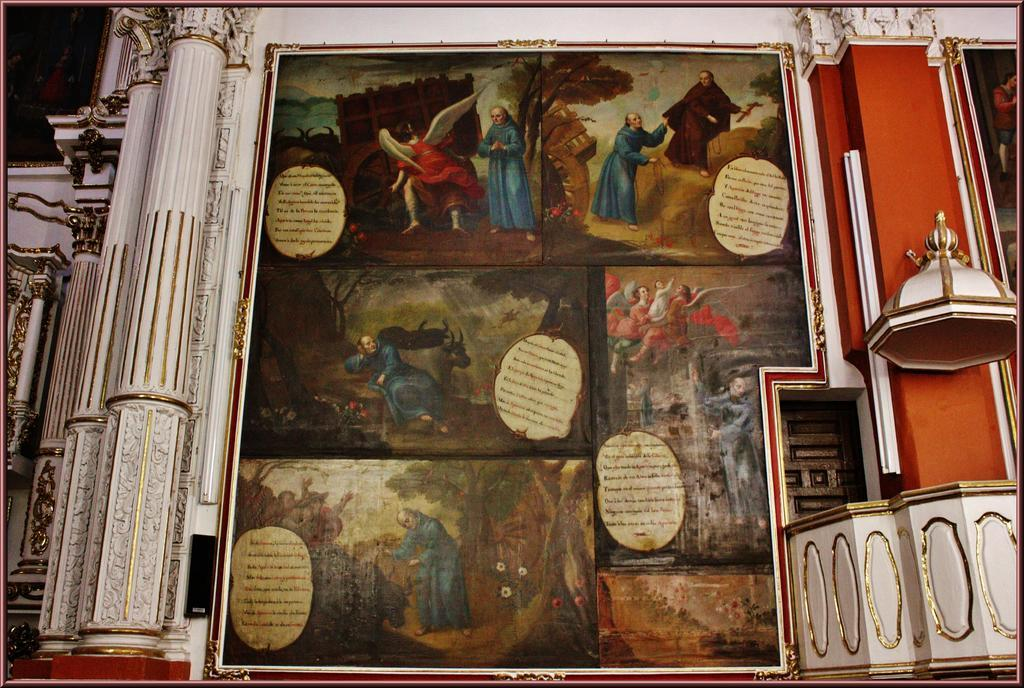What is on the wall in the image? There is an art piece on the wall in the image. What architectural feature can be seen on the left side of the image? There are pillars on the left side of the image. Can you see a snake slithering on the floor in the image? There is no snake present in the image. What color is the spoon that your mom is holding in the image? There is no spoon or mom present in the image. 